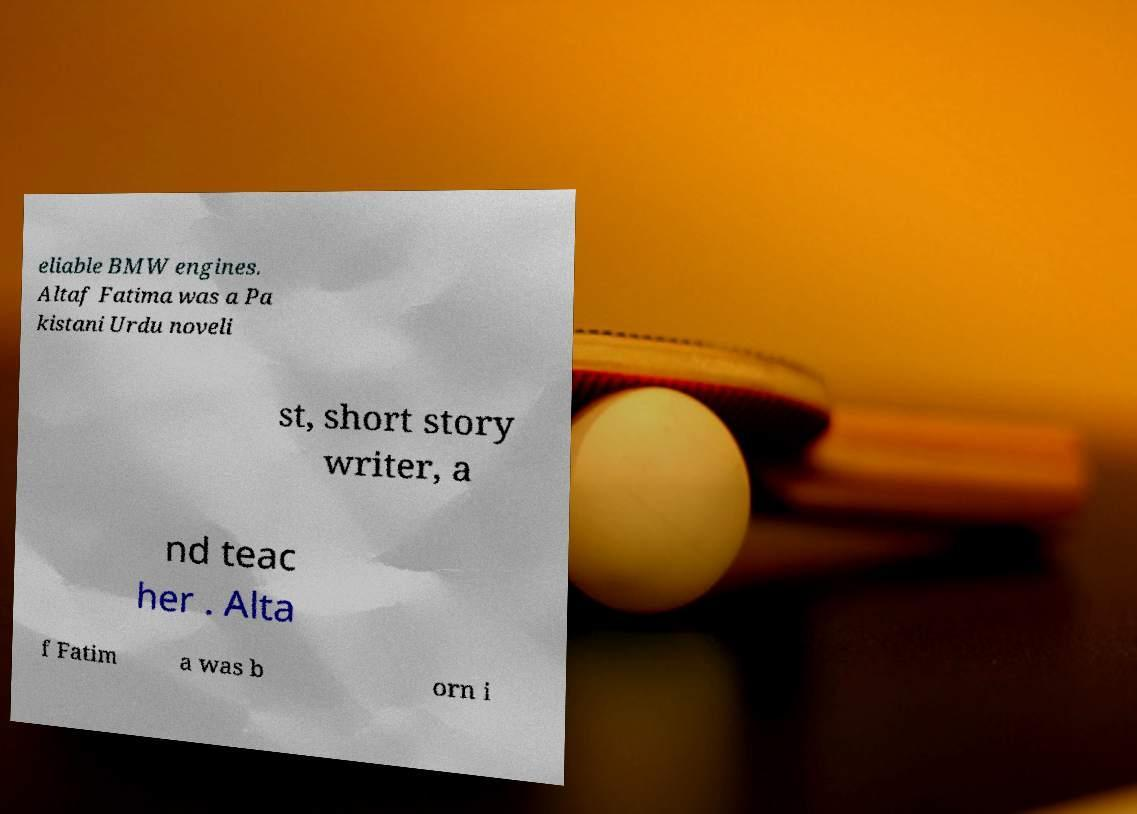Can you accurately transcribe the text from the provided image for me? eliable BMW engines. Altaf Fatima was a Pa kistani Urdu noveli st, short story writer, a nd teac her . Alta f Fatim a was b orn i 